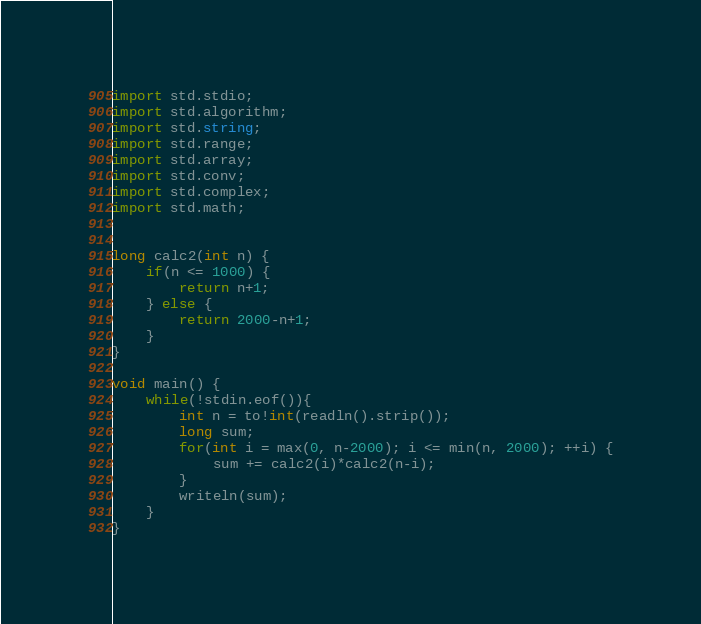<code> <loc_0><loc_0><loc_500><loc_500><_D_>import std.stdio;
import std.algorithm;
import std.string;
import std.range;
import std.array;
import std.conv;
import std.complex;
import std.math;


long calc2(int n) {
	if(n <= 1000) {
		return n+1;
	} else {
		return 2000-n+1;
	}
}

void main() {
	while(!stdin.eof()){
		int n = to!int(readln().strip());
		long sum;
		for(int i = max(0, n-2000); i <= min(n, 2000); ++i) {
			sum += calc2(i)*calc2(n-i);
		}
		writeln(sum);
	}
}</code> 